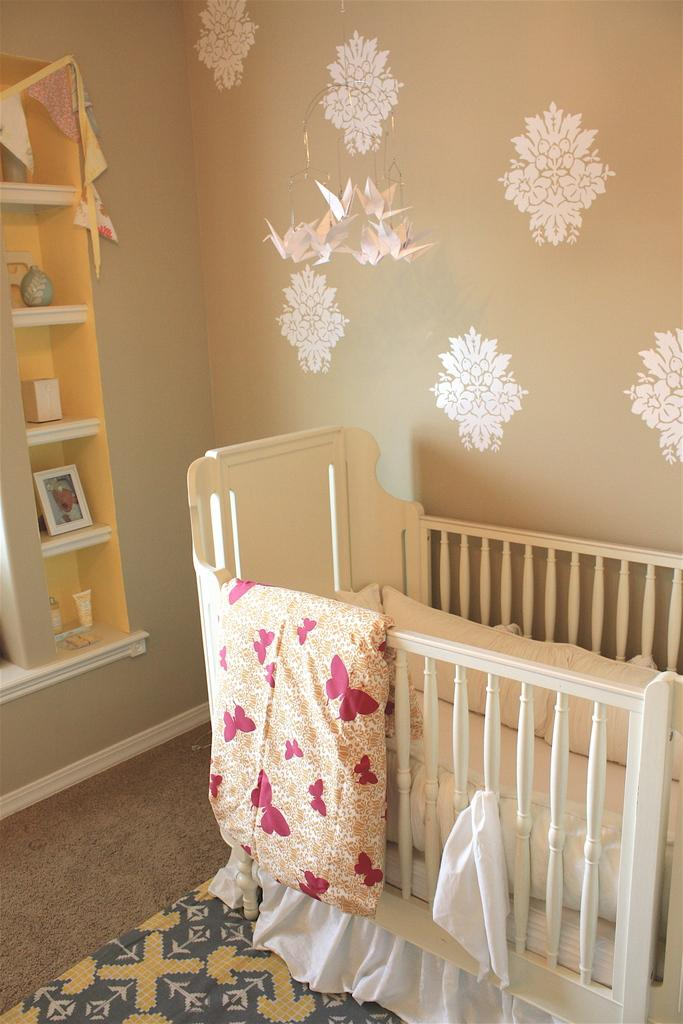What type of furniture is in the image? There is an infant bed in the image. What is behind the bed? There is a wall behind the bed. What can be seen on the cabinet in front of the wall? There are shelves on a cabinet in front of the wall. What type of mint is growing on the road outside the window in the image? There is no mention of a window or a road in the image, and no mint is present. 